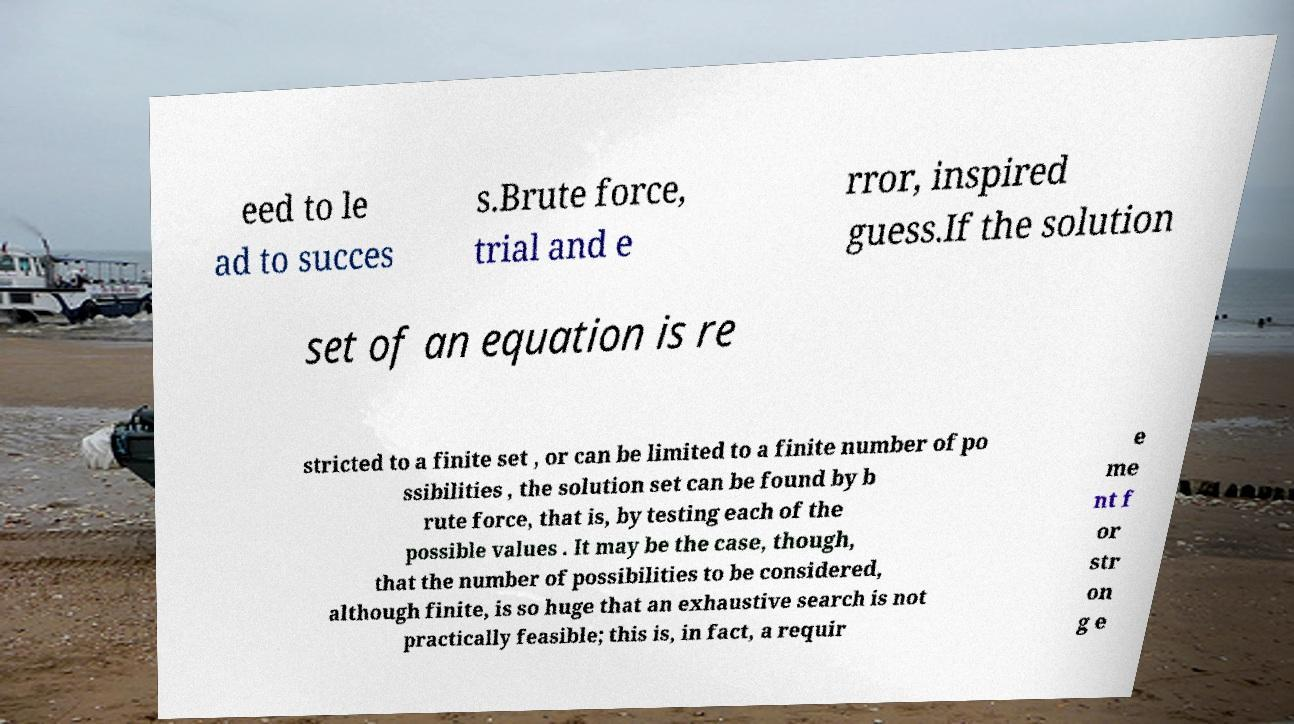Could you assist in decoding the text presented in this image and type it out clearly? eed to le ad to succes s.Brute force, trial and e rror, inspired guess.If the solution set of an equation is re stricted to a finite set , or can be limited to a finite number of po ssibilities , the solution set can be found by b rute force, that is, by testing each of the possible values . It may be the case, though, that the number of possibilities to be considered, although finite, is so huge that an exhaustive search is not practically feasible; this is, in fact, a requir e me nt f or str on g e 